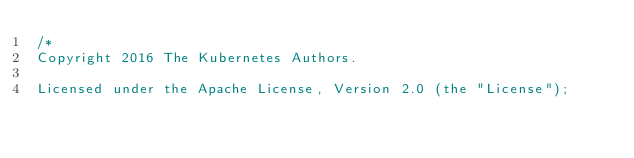Convert code to text. <code><loc_0><loc_0><loc_500><loc_500><_Go_>/*
Copyright 2016 The Kubernetes Authors.

Licensed under the Apache License, Version 2.0 (the "License");</code> 